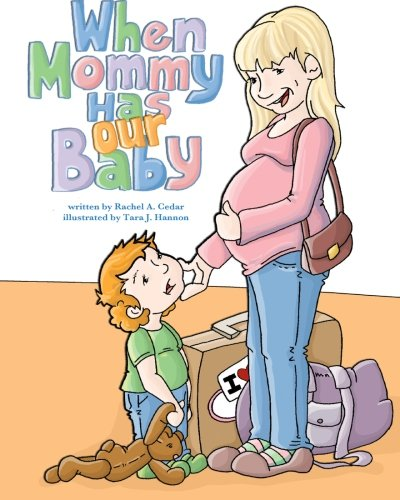How would you describe the relationship between the characters shown in the image? The image portrays a warm and affectionate relationship between a mother and her son, who seems curious and possibly excited about the new baby, as indicated by his positioning and the way he looks up to his mother. 